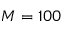<formula> <loc_0><loc_0><loc_500><loc_500>M = 1 0 0</formula> 